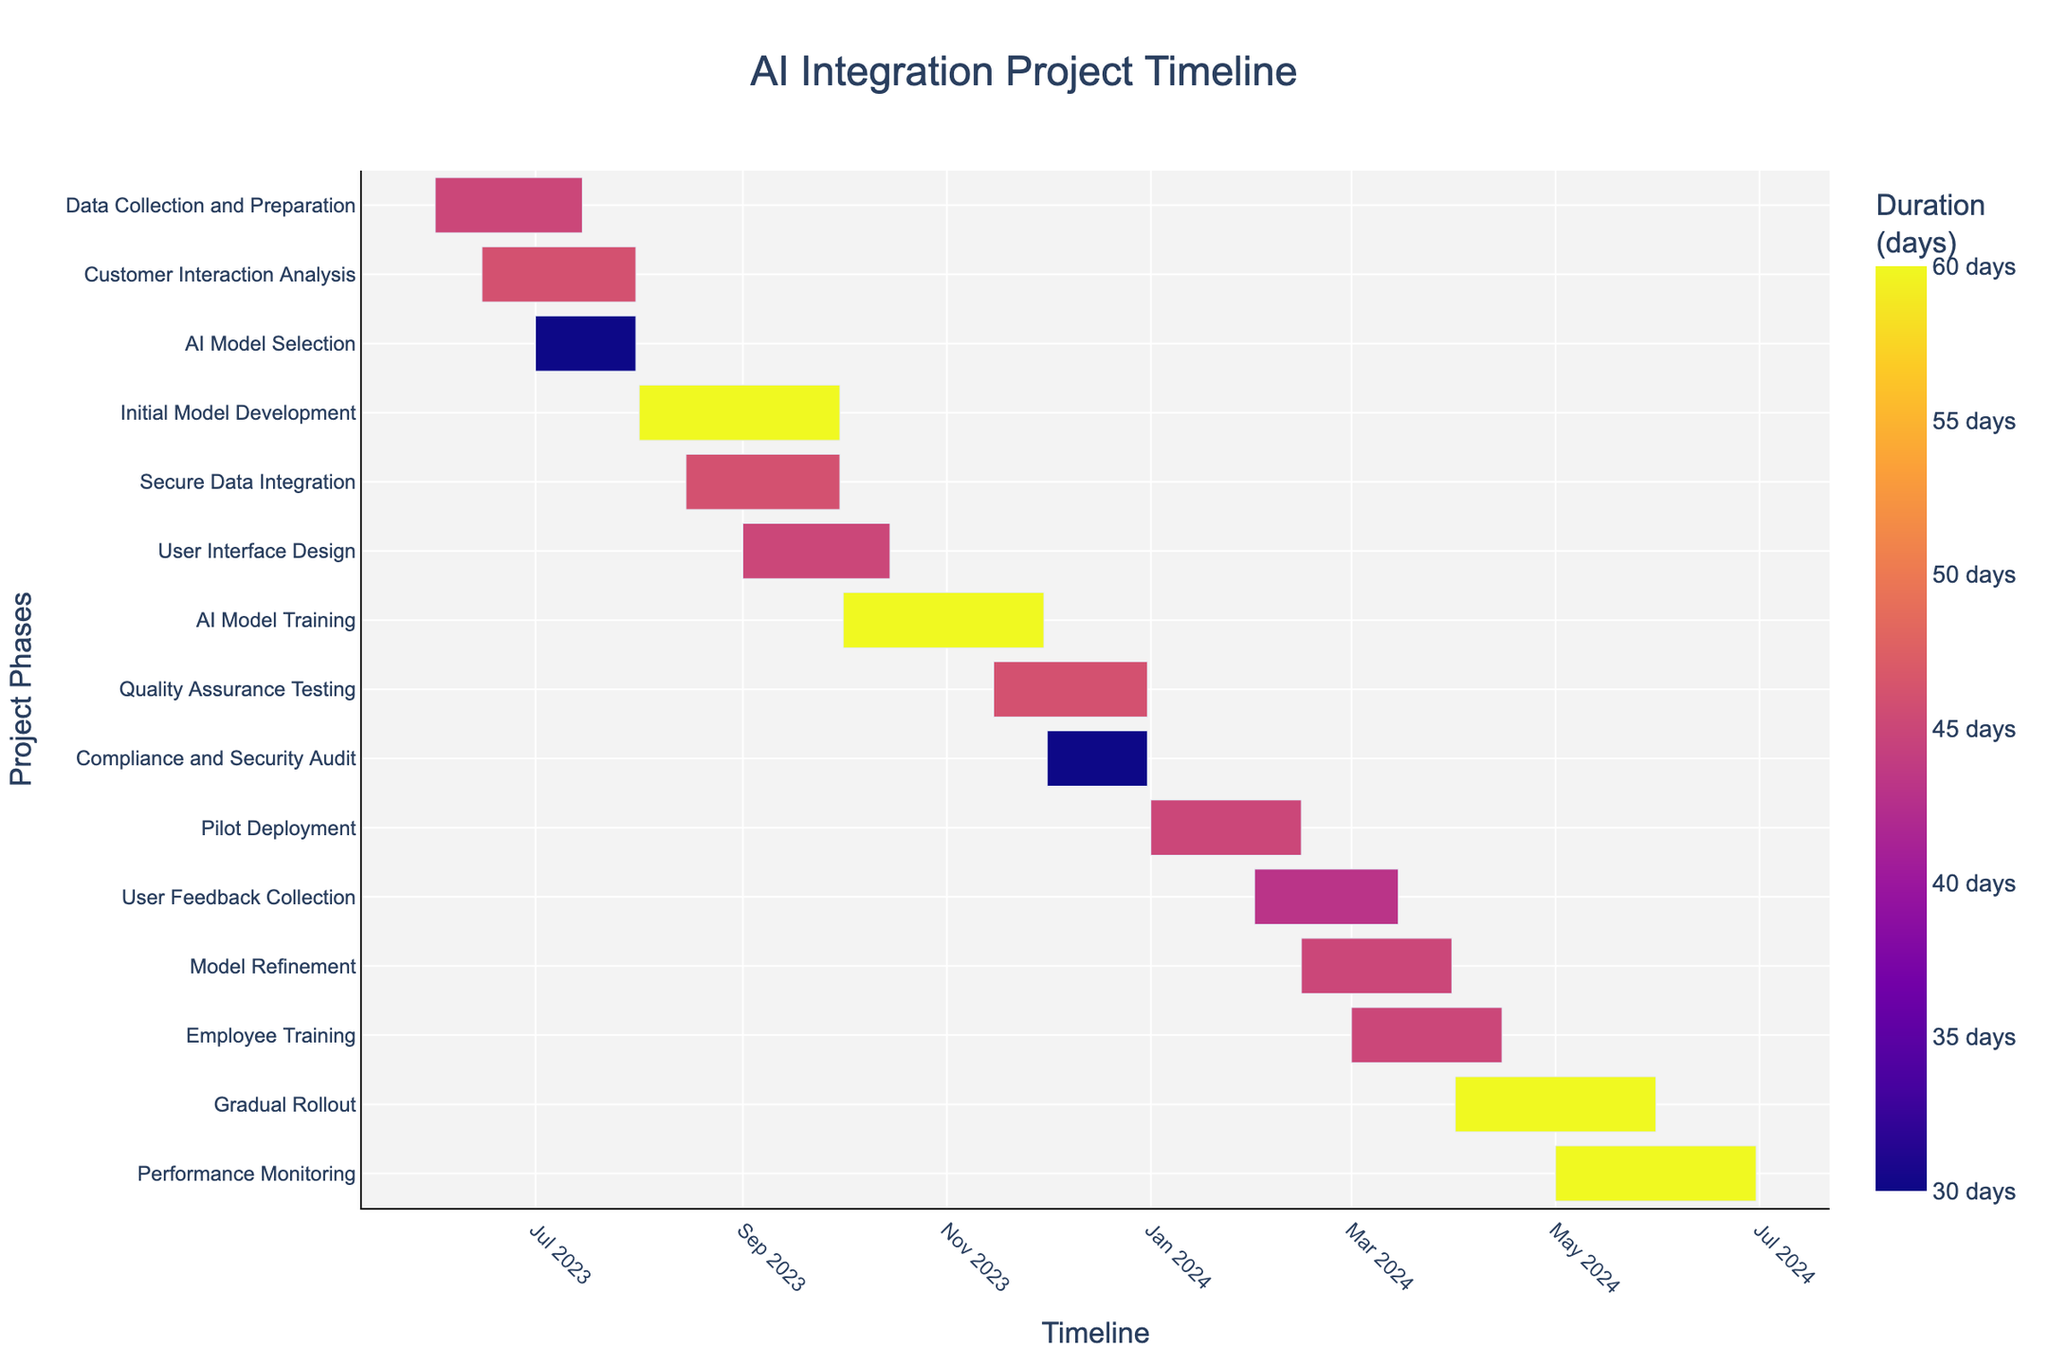What's the duration of the Data Collection and Preparation phase? The duration of the Data Collection and Preparation phase is explicitly mentioned as 45 days in the Duration column.
Answer: 45 days Which phase starts at the earliest? By examining the start dates of each phase, the Data Collection and Preparation phase starts the earliest on 2023-06-01.
Answer: Data Collection and Preparation How much time is allocated for the AI Model Training phase? The duration of the AI Model Training phase is directly given as 60 days.
Answer: 60 days Which phase ends last in the timeline? The Performance Monitoring phase ends last, with its end date on 2024-06-30.
Answer: Performance Monitoring What is the overlap period between Data Collection and Preparation and Customer Interaction Analysis? Data Collection and Preparation starts on 2023-06-01 and ends on 2023-07-15. Customer Interaction Analysis starts on 2023-06-15 and ends on 2023-07-31. The overlap period is from 2023-06-15 to 2023-07-15.
Answer: 31 days Which phase is shorter: Compliance and Security Audit or AI Model Selection? The Compliance and Security Audit phase has a 30-day duration while the AI Model Selection phase is also 30 days. Therefore, their durations are equal.
Answer: Equal Between Initial Model Development and User Interface Design, which one starts first and by how many days? Initial Model Development starts on 2023-08-01, while User Interface Design starts on 2023-09-01. Therefore, Initial Model Development starts 31 days earlier.
Answer: Initial Model Development, 31 days How long is Performance Monitoring phase in comparison to the Gradual Rollout phase? Both the Performance Monitoring phase and the Gradual Rollout phase have the same duration of 60 days.
Answer: Same What is the latest start date observed in the chart? The latest start date is for the Performance Monitoring phase, which starts on 2024-05-01.
Answer: 2024-05-01 Can you list all phases that end in December 2023? Secure Data Integration ends on 2023-09-30, Quality Assurance Testing ends on 2023-12-31, Compliance and Security Audit ends on 2023-12-31. Therefore, Quality Assurance Testing and Compliance and Security Audit are the phases that end in December 2023.
Answer: Quality Assurance Testing, Compliance and Security Audit 